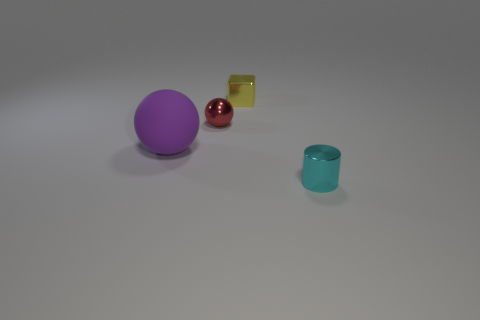Is the shape of the metallic thing that is in front of the large matte ball the same as the tiny thing that is behind the small red shiny ball?
Provide a succinct answer. No. What color is the tiny sphere that is made of the same material as the small cyan object?
Give a very brief answer. Red. Are there fewer large rubber spheres that are to the left of the small cyan shiny cylinder than purple rubber spheres?
Your response must be concise. No. How big is the ball behind the sphere that is to the left of the sphere behind the purple sphere?
Ensure brevity in your answer.  Small. Does the tiny object that is to the left of the yellow metal thing have the same material as the tiny block?
Your response must be concise. Yes. Are there any other things that have the same shape as the purple rubber thing?
Your response must be concise. Yes. How many things are either large objects or large cyan balls?
Provide a short and direct response. 1. What is the size of the red object that is the same shape as the large purple matte object?
Your answer should be very brief. Small. Is there anything else that is the same size as the cyan metallic object?
Offer a very short reply. Yes. What number of cubes are tiny objects or small red metallic objects?
Provide a short and direct response. 1. 